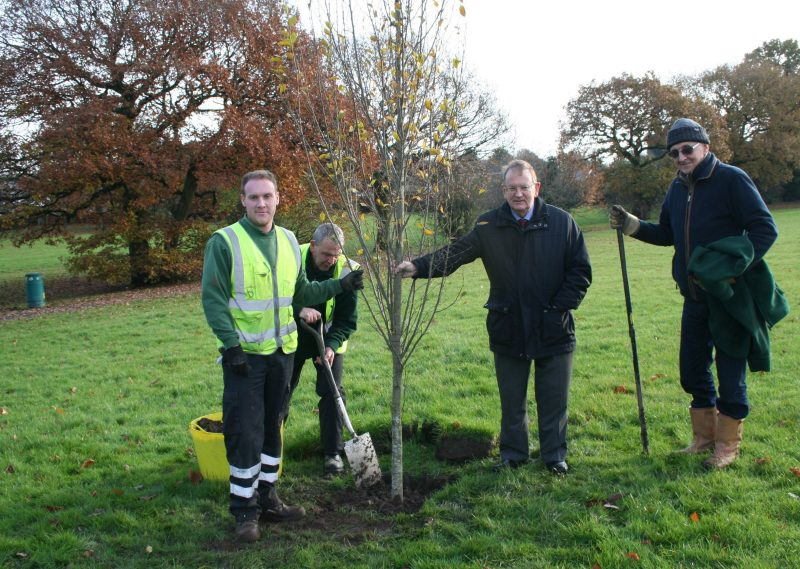What specific tools are the individuals using, and what is each person’s role in this tree planting process? In the image, the individuals are using basic hand tools commonly used in tree planting activities. One person is holding a shovel, which is used for digging the hole needed to plant the tree. Another individual is observing while the person with the shovel is actively engaged in the planting process. The third person appears to be helping guide the tree into its new position, ensuring it is planted correctly and upright. The fourth individual, who is an older man, seems to be overseeing the activities, possibly in a supervisory or ceremonial role. This arrangement suggests a collaborative effort, with each person contributing to the successful planting of the tree. Why might this particular spot have been chosen for planting the tree? This particular spot may have been chosen for planting the tree due to several factors. Firstly, the open grassy area provides ample space for the tree's roots to grow without interference from other plants or structures. Secondly, the location within a park suggests a public area where the tree can be enjoyed by many people, enhancing the aesthetics and environmental quality of the space. Additionally, the park setting ensures that the tree will be well-maintained and protected. The presence of mature trees nearby also indicates that this area has suitable soil and environmental conditions for tree growth. Imagine the tree grows over the next fifty years. What changes might this park undergo with the tree's growth? As the tree grows over the next fifty years, the park is likely to undergo significant changes, both visually and ecologically. The tree will grow to be tall and robust, casting a generous amount of shade over the surrounding area. This will create a cooler, more comfortable place for park-goers to rest and picnic. Its canopy will provide shelter for various birds and small animals, increasing local biodiversity. The tree’s root system will help prevent soil erosion and improve water retention in the ground, contributing to the overall health of the park's ecosystem.

As the tree matures, it might become a central feature of the park, around which paths, benches, and flowerbeds could be arranged. The tree might witness countless community events, from picnics and festivals to people seeking solace under its branches. It will become a living witness to the lives of many generations, embodying the passage of time and the growth of the community.

With time, the park might also see other trees and plants being added, possibly inspired by the success and beauty of this tree. The area surrounding the tree could evolve into a lush, green haven, attracting not just local residents but also visitors from afar. The positive environmental impact of the tree will manifest in cleaner air and a more vibrant ecosystem, making the park a cherished and iconic green space in the community. 